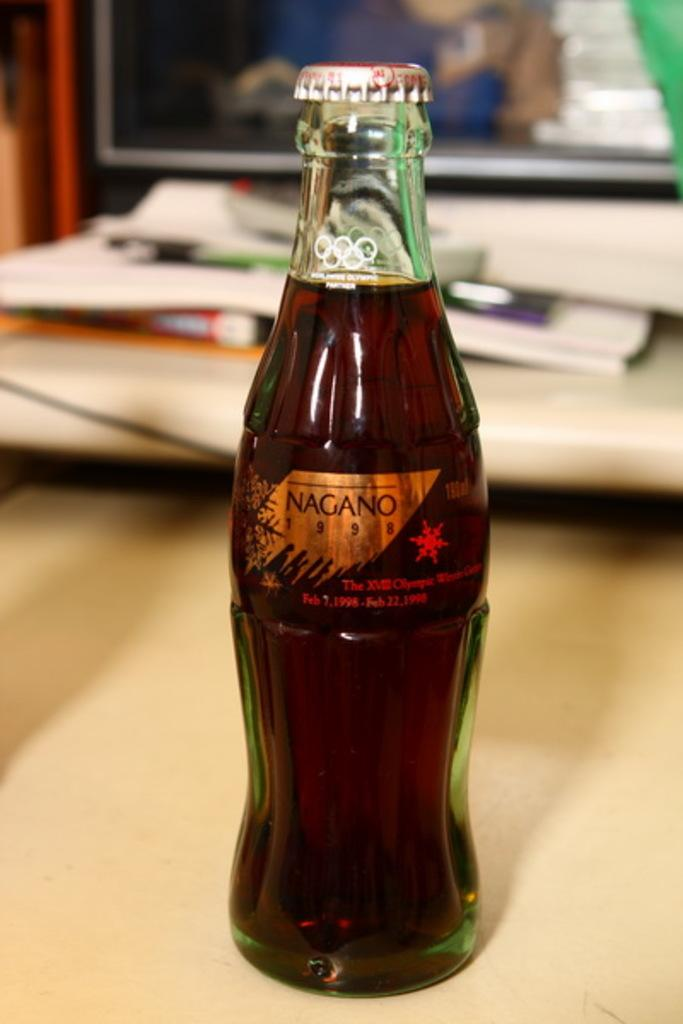<image>
Provide a brief description of the given image. a NAGANO pop bottle that is unopened. 